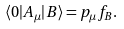<formula> <loc_0><loc_0><loc_500><loc_500>\langle 0 | A _ { \mu } | B \rangle = p _ { \mu } f _ { B } .</formula> 